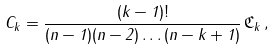<formula> <loc_0><loc_0><loc_500><loc_500>C _ { k } = \frac { ( k - 1 ) ! } { ( n - 1 ) ( n - 2 ) \dots ( n - k + 1 ) } \, \mathfrak { C } _ { k } \, ,</formula> 